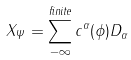<formula> <loc_0><loc_0><loc_500><loc_500>X _ { \Psi } = \sum _ { - \infty } ^ { f i n i t e } c ^ { \alpha } ( \phi ) D _ { \alpha }</formula> 